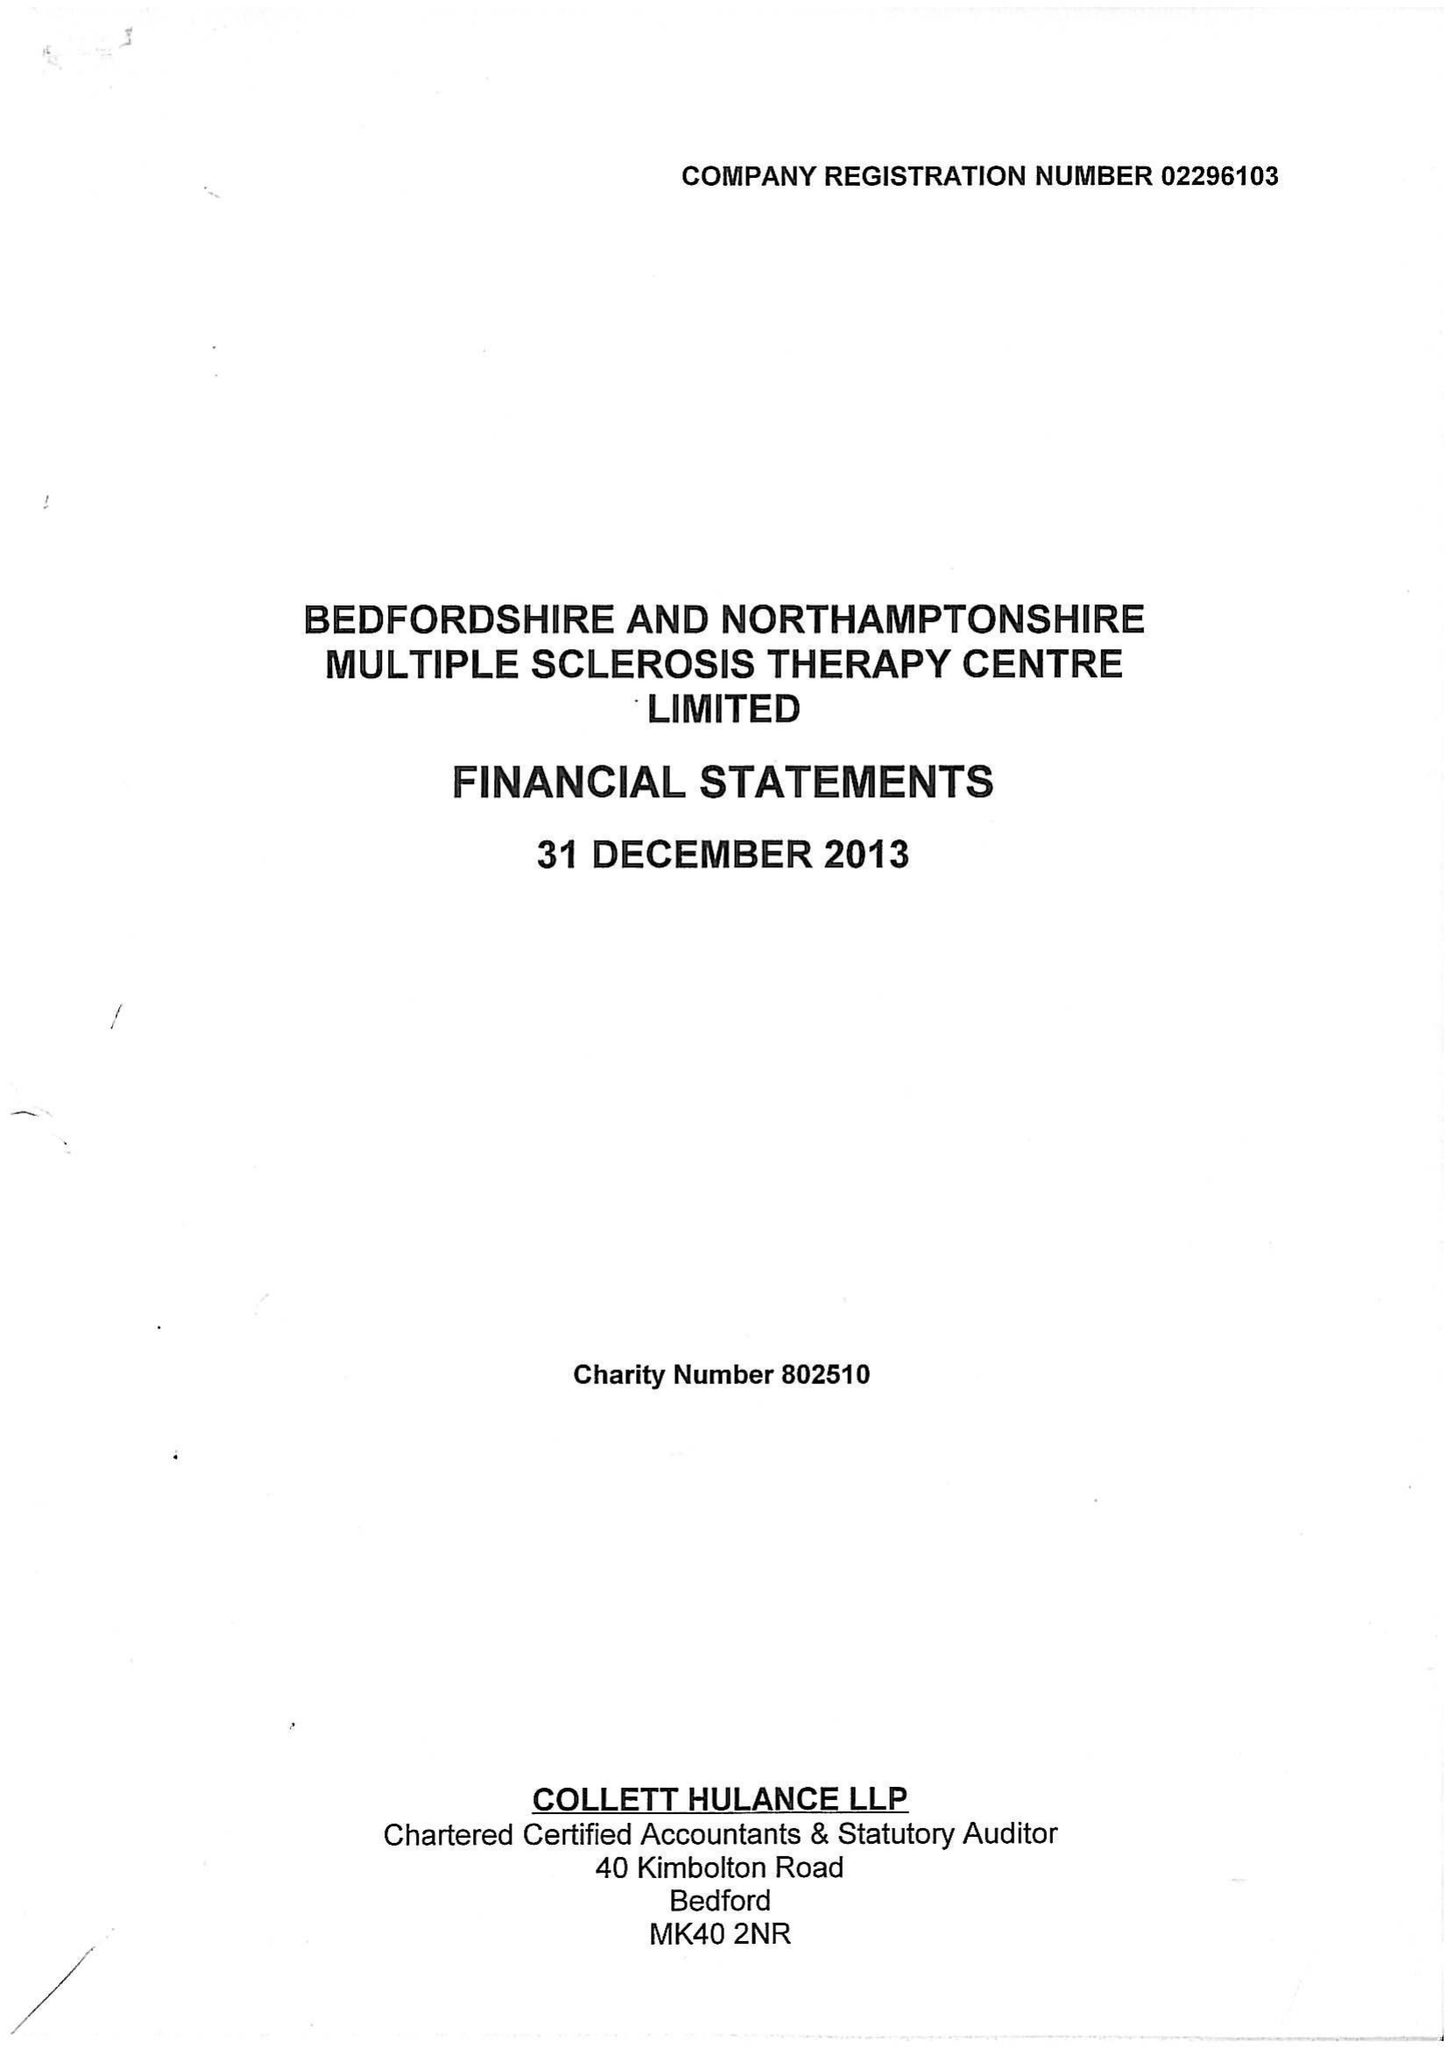What is the value for the address__postcode?
Answer the question using a single word or phrase. MK41 9RX 